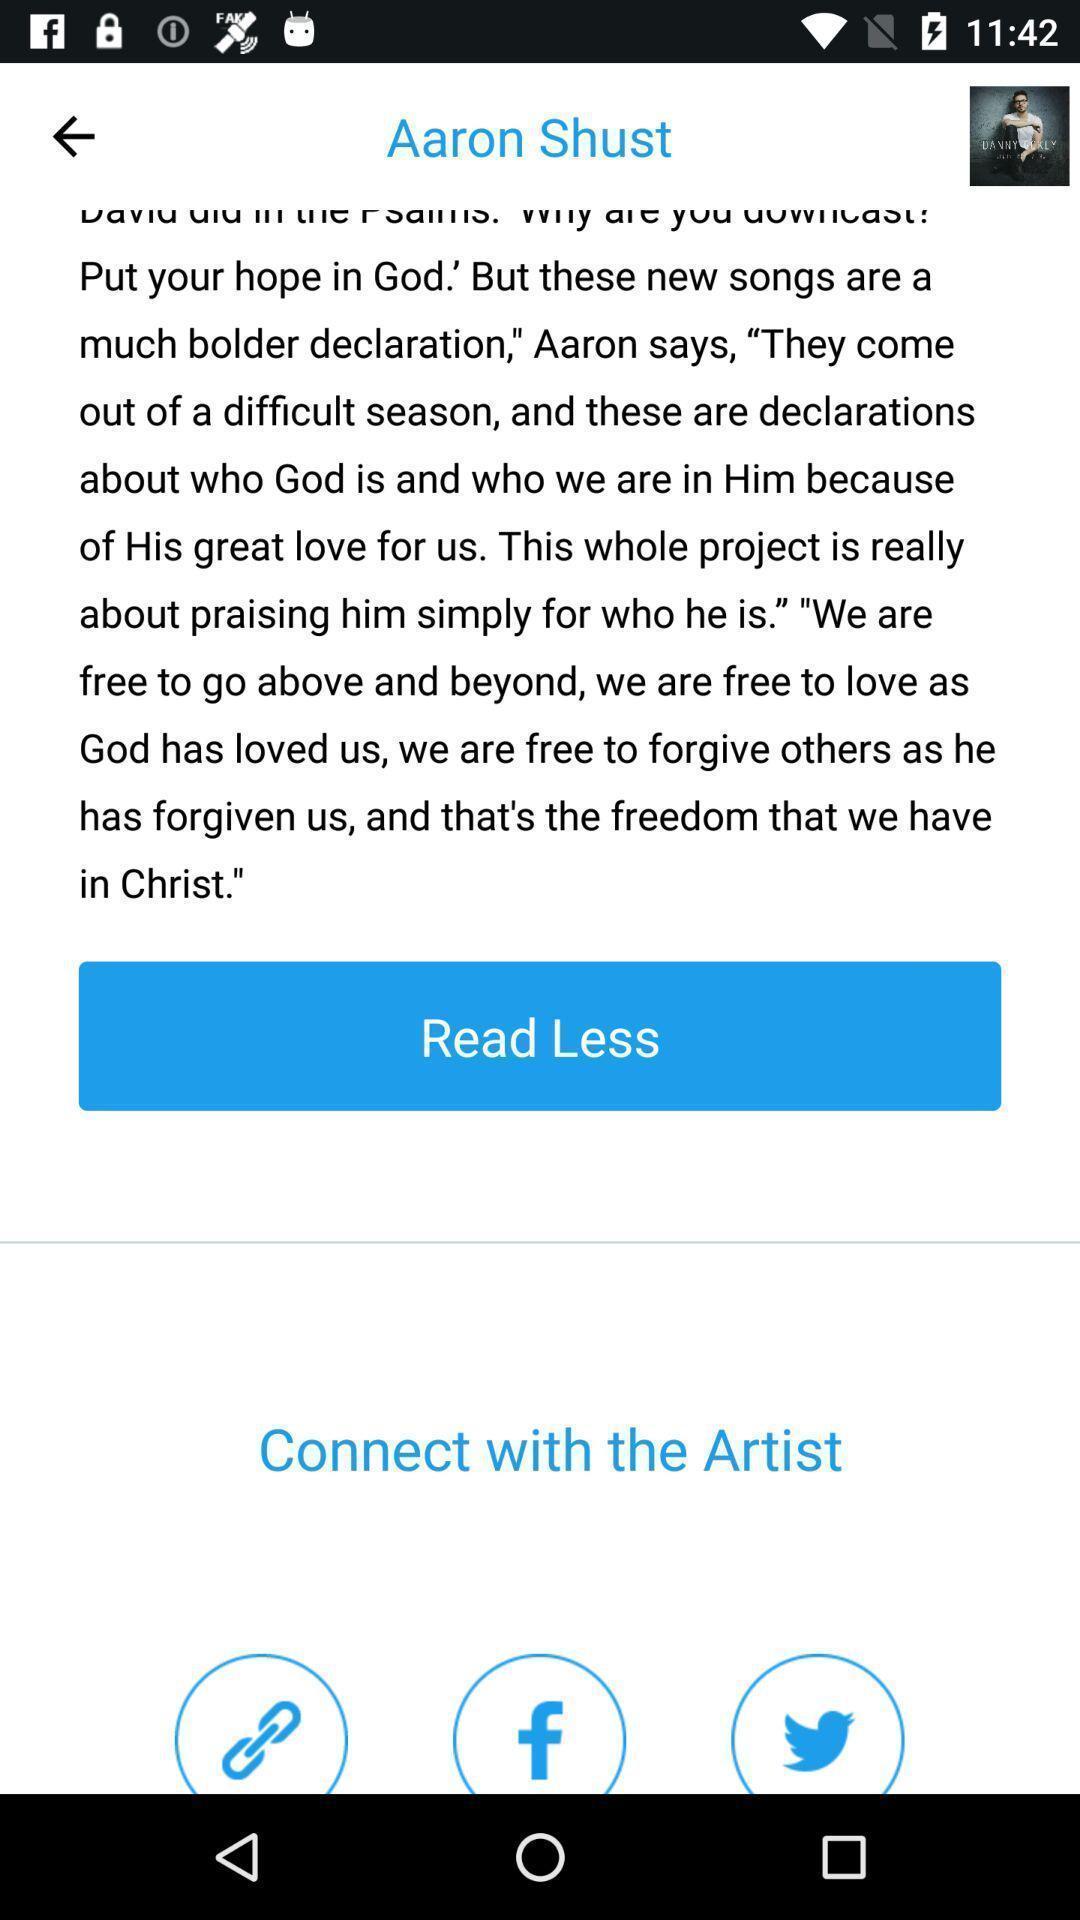Summarize the information in this screenshot. Screen showing an article in a web page. 